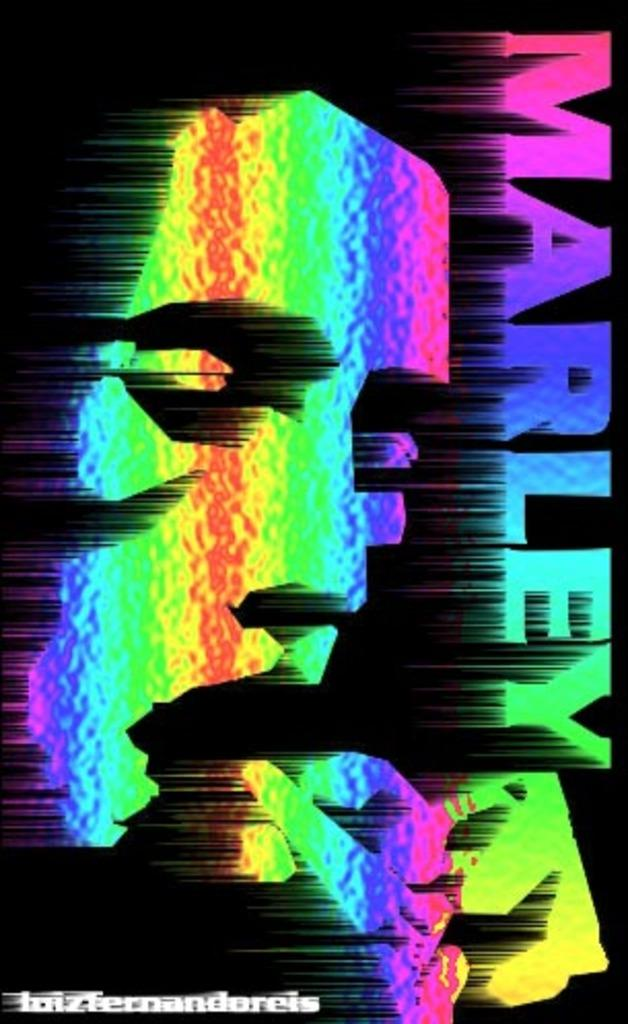Provide a one-sentence caption for the provided image. A rainbow colored Marley poster with black background. 